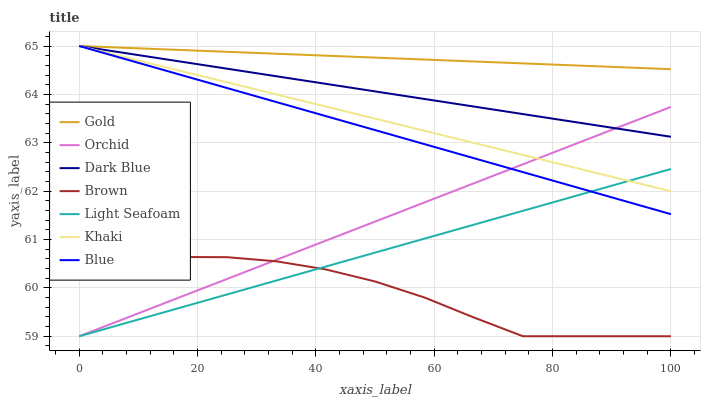Does Khaki have the minimum area under the curve?
Answer yes or no. No. Does Khaki have the maximum area under the curve?
Answer yes or no. No. Is Brown the smoothest?
Answer yes or no. No. Is Khaki the roughest?
Answer yes or no. No. Does Khaki have the lowest value?
Answer yes or no. No. Does Brown have the highest value?
Answer yes or no. No. Is Brown less than Blue?
Answer yes or no. Yes. Is Gold greater than Light Seafoam?
Answer yes or no. Yes. Does Brown intersect Blue?
Answer yes or no. No. 